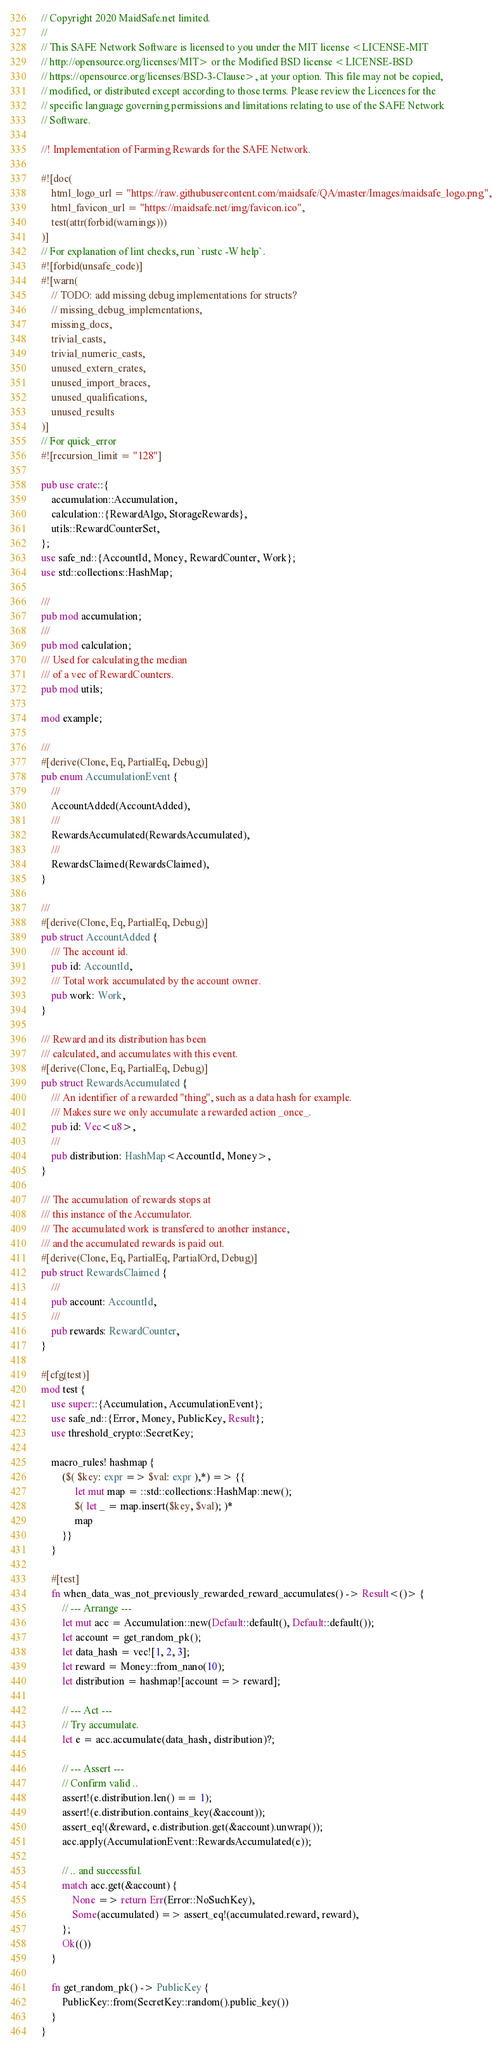Convert code to text. <code><loc_0><loc_0><loc_500><loc_500><_Rust_>// Copyright 2020 MaidSafe.net limited.
//
// This SAFE Network Software is licensed to you under the MIT license <LICENSE-MIT
// http://opensource.org/licenses/MIT> or the Modified BSD license <LICENSE-BSD
// https://opensource.org/licenses/BSD-3-Clause>, at your option. This file may not be copied,
// modified, or distributed except according to those terms. Please review the Licences for the
// specific language governing permissions and limitations relating to use of the SAFE Network
// Software.

//! Implementation of Farming Rewards for the SAFE Network.

#![doc(
    html_logo_url = "https://raw.githubusercontent.com/maidsafe/QA/master/Images/maidsafe_logo.png",
    html_favicon_url = "https://maidsafe.net/img/favicon.ico",
    test(attr(forbid(warnings)))
)]
// For explanation of lint checks, run `rustc -W help`.
#![forbid(unsafe_code)]
#![warn(
    // TODO: add missing debug implementations for structs?
    // missing_debug_implementations,
    missing_docs,
    trivial_casts,
    trivial_numeric_casts,
    unused_extern_crates,
    unused_import_braces,
    unused_qualifications,
    unused_results
)]
// For quick_error
#![recursion_limit = "128"]

pub use crate::{
    accumulation::Accumulation,
    calculation::{RewardAlgo, StorageRewards},
    utils::RewardCounterSet,
};
use safe_nd::{AccountId, Money, RewardCounter, Work};
use std::collections::HashMap;

///
pub mod accumulation;
///
pub mod calculation;
/// Used for calculating the median
/// of a vec of RewardCounters.
pub mod utils;

mod example;

///
#[derive(Clone, Eq, PartialEq, Debug)]
pub enum AccumulationEvent {
    ///
    AccountAdded(AccountAdded),
    ///
    RewardsAccumulated(RewardsAccumulated),
    ///
    RewardsClaimed(RewardsClaimed),
}

///
#[derive(Clone, Eq, PartialEq, Debug)]
pub struct AccountAdded {
    /// The account id.
    pub id: AccountId,
    /// Total work accumulated by the account owner.
    pub work: Work,
}

/// Reward and its distribution has been
/// calculated, and accumulates with this event.
#[derive(Clone, Eq, PartialEq, Debug)]
pub struct RewardsAccumulated {
    /// An identifier of a rewarded "thing", such as a data hash for example.
    /// Makes sure we only accumulate a rewarded action _once_.
    pub id: Vec<u8>,
    ///
    pub distribution: HashMap<AccountId, Money>,
}

/// The accumulation of rewards stops at
/// this instance of the Accumulator.
/// The accumulated work is transfered to another instance,
/// and the accumulated rewards is paid out.
#[derive(Clone, Eq, PartialEq, PartialOrd, Debug)]
pub struct RewardsClaimed {
    ///
    pub account: AccountId,
    ///
    pub rewards: RewardCounter,
}

#[cfg(test)]
mod test {
    use super::{Accumulation, AccumulationEvent};
    use safe_nd::{Error, Money, PublicKey, Result};
    use threshold_crypto::SecretKey;

    macro_rules! hashmap {
        ($( $key: expr => $val: expr ),*) => {{
             let mut map = ::std::collections::HashMap::new();
             $( let _ = map.insert($key, $val); )*
             map
        }}
    }

    #[test]
    fn when_data_was_not_previously_rewarded_reward_accumulates() -> Result<()> {
        // --- Arrange ---
        let mut acc = Accumulation::new(Default::default(), Default::default());
        let account = get_random_pk();
        let data_hash = vec![1, 2, 3];
        let reward = Money::from_nano(10);
        let distribution = hashmap![account => reward];

        // --- Act ---
        // Try accumulate.
        let e = acc.accumulate(data_hash, distribution)?;

        // --- Assert ---
        // Confirm valid ..
        assert!(e.distribution.len() == 1);
        assert!(e.distribution.contains_key(&account));
        assert_eq!(&reward, e.distribution.get(&account).unwrap());
        acc.apply(AccumulationEvent::RewardsAccumulated(e));

        // .. and successful.
        match acc.get(&account) {
            None => return Err(Error::NoSuchKey),
            Some(accumulated) => assert_eq!(accumulated.reward, reward),
        };
        Ok(())
    }

    fn get_random_pk() -> PublicKey {
        PublicKey::from(SecretKey::random().public_key())
    }
}
</code> 